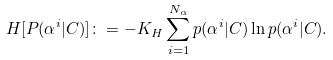Convert formula to latex. <formula><loc_0><loc_0><loc_500><loc_500>H [ P ( \alpha ^ { i } | C ) ] \colon = - K _ { H } \sum _ { i = 1 } ^ { N _ { \alpha } } p ( \alpha ^ { i } | C ) \ln p ( \alpha ^ { i } | C ) .</formula> 